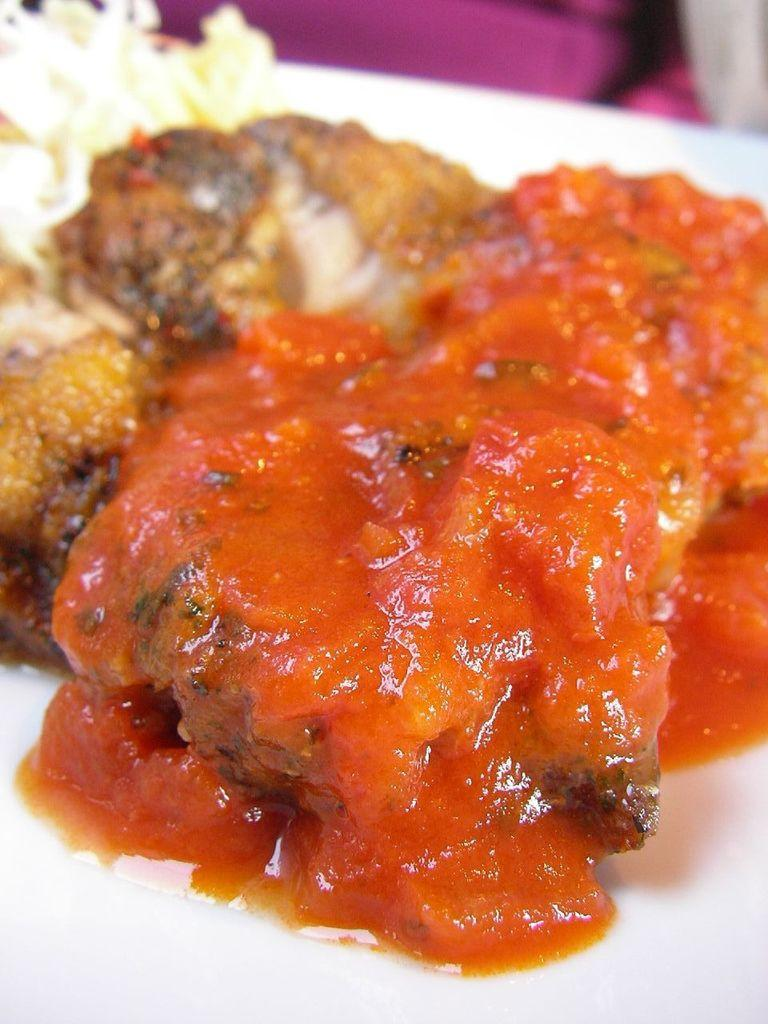What is on the plate in the image? There is food on a plate in the image. What type of metal can be seen in the image? There is no metal present in the image; it only features a plate of food. How many teeth can be seen in the image? There are no teeth visible in the image, as it only features a plate of food. 